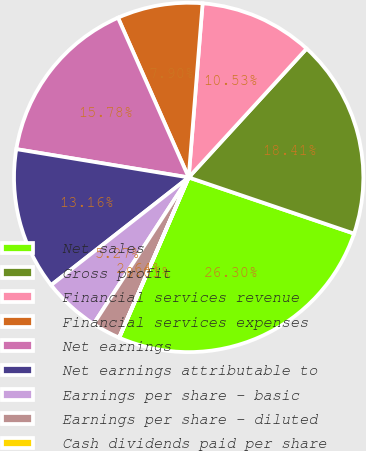Convert chart. <chart><loc_0><loc_0><loc_500><loc_500><pie_chart><fcel>Net sales<fcel>Gross profit<fcel>Financial services revenue<fcel>Financial services expenses<fcel>Net earnings<fcel>Net earnings attributable to<fcel>Earnings per share - basic<fcel>Earnings per share - diluted<fcel>Cash dividends paid per share<nl><fcel>26.3%<fcel>18.41%<fcel>10.53%<fcel>7.9%<fcel>15.78%<fcel>13.16%<fcel>5.27%<fcel>2.64%<fcel>0.01%<nl></chart> 